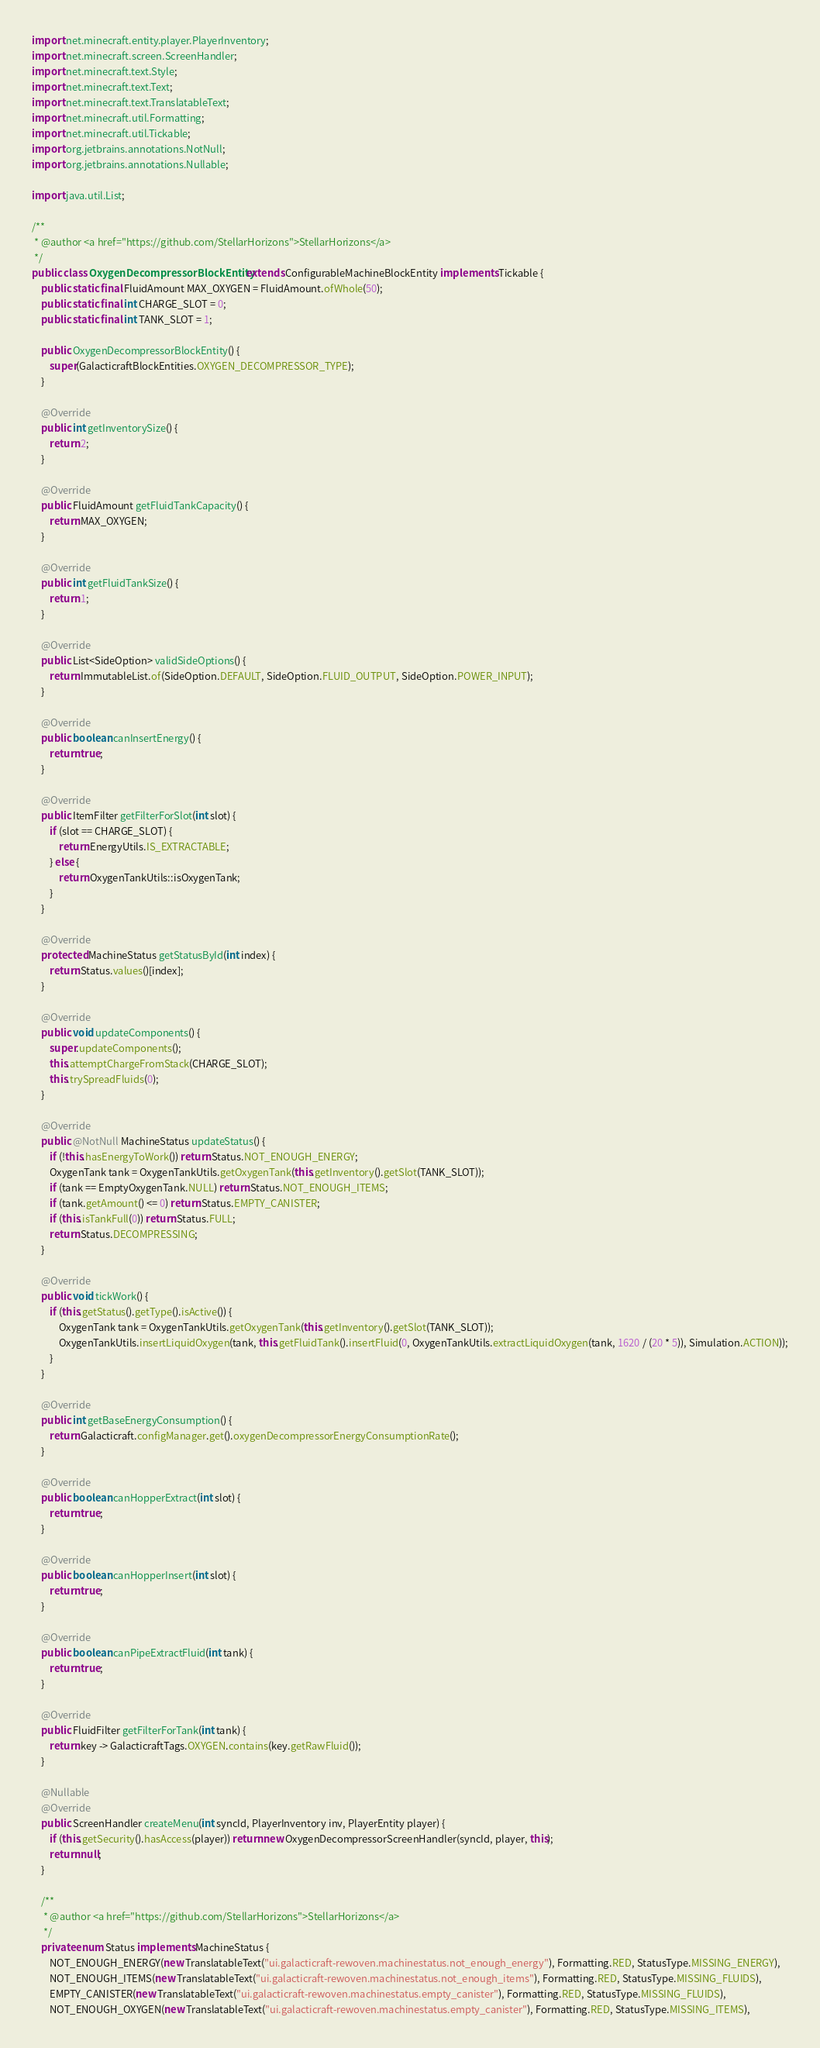<code> <loc_0><loc_0><loc_500><loc_500><_Java_>import net.minecraft.entity.player.PlayerInventory;
import net.minecraft.screen.ScreenHandler;
import net.minecraft.text.Style;
import net.minecraft.text.Text;
import net.minecraft.text.TranslatableText;
import net.minecraft.util.Formatting;
import net.minecraft.util.Tickable;
import org.jetbrains.annotations.NotNull;
import org.jetbrains.annotations.Nullable;

import java.util.List;

/**
 * @author <a href="https://github.com/StellarHorizons">StellarHorizons</a>
 */
public class OxygenDecompressorBlockEntity extends ConfigurableMachineBlockEntity implements Tickable {
    public static final FluidAmount MAX_OXYGEN = FluidAmount.ofWhole(50);
    public static final int CHARGE_SLOT = 0;
    public static final int TANK_SLOT = 1;

    public OxygenDecompressorBlockEntity() {
        super(GalacticraftBlockEntities.OXYGEN_DECOMPRESSOR_TYPE);
    }

    @Override
    public int getInventorySize() {
        return 2;
    }

    @Override
    public FluidAmount getFluidTankCapacity() {
        return MAX_OXYGEN;
    }

    @Override
    public int getFluidTankSize() {
        return 1;
    }

    @Override
    public List<SideOption> validSideOptions() {
        return ImmutableList.of(SideOption.DEFAULT, SideOption.FLUID_OUTPUT, SideOption.POWER_INPUT);
    }

    @Override
    public boolean canInsertEnergy() {
        return true;
    }

    @Override
    public ItemFilter getFilterForSlot(int slot) {
        if (slot == CHARGE_SLOT) {
            return EnergyUtils.IS_EXTRACTABLE;
        } else {
            return OxygenTankUtils::isOxygenTank;
        }
    }

    @Override
    protected MachineStatus getStatusById(int index) {
        return Status.values()[index];
    }

    @Override
    public void updateComponents() {
        super.updateComponents();
        this.attemptChargeFromStack(CHARGE_SLOT);
        this.trySpreadFluids(0);
    }

    @Override
    public @NotNull MachineStatus updateStatus() {
        if (!this.hasEnergyToWork()) return Status.NOT_ENOUGH_ENERGY;
        OxygenTank tank = OxygenTankUtils.getOxygenTank(this.getInventory().getSlot(TANK_SLOT));
        if (tank == EmptyOxygenTank.NULL) return Status.NOT_ENOUGH_ITEMS;
        if (tank.getAmount() <= 0) return Status.EMPTY_CANISTER;
        if (this.isTankFull(0)) return Status.FULL;
        return Status.DECOMPRESSING;
    }

    @Override
    public void tickWork() {
        if (this.getStatus().getType().isActive()) {
            OxygenTank tank = OxygenTankUtils.getOxygenTank(this.getInventory().getSlot(TANK_SLOT));
            OxygenTankUtils.insertLiquidOxygen(tank, this.getFluidTank().insertFluid(0, OxygenTankUtils.extractLiquidOxygen(tank, 1620 / (20 * 5)), Simulation.ACTION));
        }
    }

    @Override
    public int getBaseEnergyConsumption() {
        return Galacticraft.configManager.get().oxygenDecompressorEnergyConsumptionRate();
    }

    @Override
    public boolean canHopperExtract(int slot) {
        return true;
    }

    @Override
    public boolean canHopperInsert(int slot) {
        return true;
    }

    @Override
    public boolean canPipeExtractFluid(int tank) {
        return true;
    }

    @Override
    public FluidFilter getFilterForTank(int tank) {
        return key -> GalacticraftTags.OXYGEN.contains(key.getRawFluid());
    }

    @Nullable
    @Override
    public ScreenHandler createMenu(int syncId, PlayerInventory inv, PlayerEntity player) {
        if (this.getSecurity().hasAccess(player)) return new OxygenDecompressorScreenHandler(syncId, player, this);
        return null;
    }

    /**
     * @author <a href="https://github.com/StellarHorizons">StellarHorizons</a>
     */
    private enum Status implements MachineStatus {
        NOT_ENOUGH_ENERGY(new TranslatableText("ui.galacticraft-rewoven.machinestatus.not_enough_energy"), Formatting.RED, StatusType.MISSING_ENERGY),
        NOT_ENOUGH_ITEMS(new TranslatableText("ui.galacticraft-rewoven.machinestatus.not_enough_items"), Formatting.RED, StatusType.MISSING_FLUIDS),
        EMPTY_CANISTER(new TranslatableText("ui.galacticraft-rewoven.machinestatus.empty_canister"), Formatting.RED, StatusType.MISSING_FLUIDS),
        NOT_ENOUGH_OXYGEN(new TranslatableText("ui.galacticraft-rewoven.machinestatus.empty_canister"), Formatting.RED, StatusType.MISSING_ITEMS),</code> 